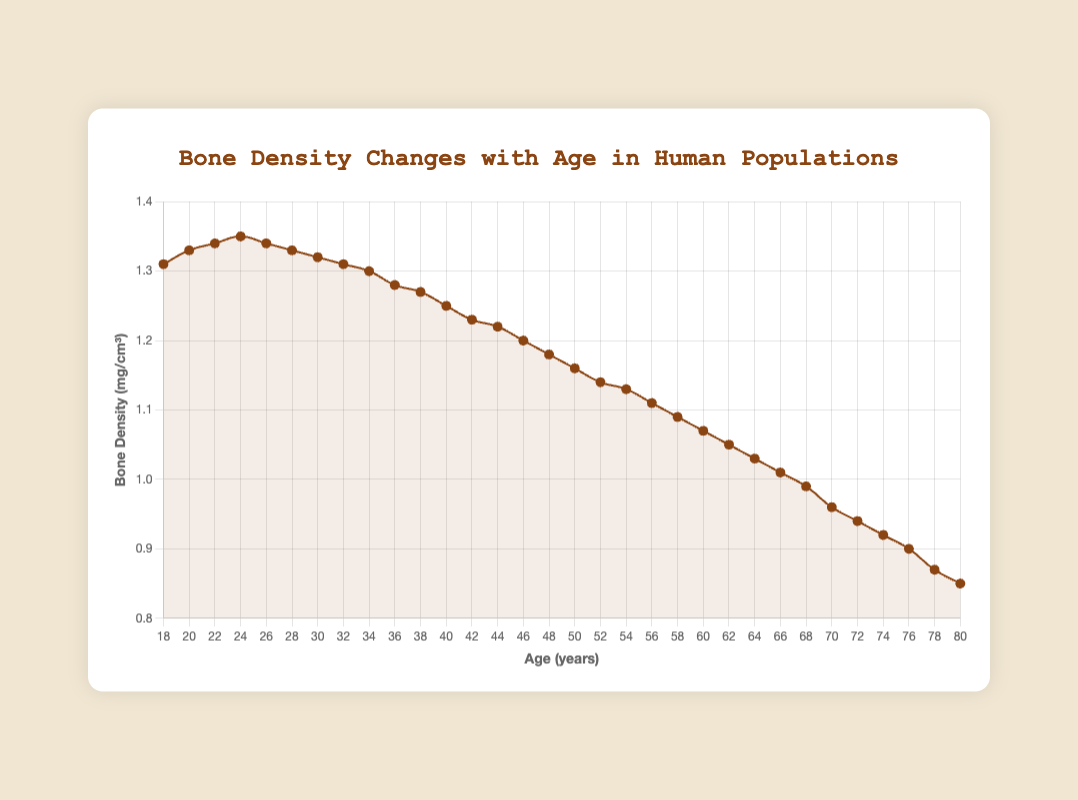How does bone density change between the ages of 18 and 28? Refer to the curve in the plot, bone density increases from 1.31 mg/cm³ to 1.33 mg/cm³ between the ages of 18 and 28.
Answer: It increases At what age does bone density peak? Inspect the peak point of the curve; bone density peaks at age 24 at 1.35 mg/cm³.
Answer: 24 years How much does bone density decline from age 24 to 50? From the figure, bone density at age 24 is 1.35 mg/cm³ and at age 50 is 1.16 mg/cm³. The decline is 1.35 - 1.16 = 0.19 mg/cm³.
Answer: 0.19 mg/cm³ Compare the bone density at ages 30 and 60. Which one is higher? The bone density at age 30 is 1.32 mg/cm³ and at age 60 is 1.07 mg/cm³. Clearly, 1.32 mg/cm³ is higher than 1.07 mg/cm³.
Answer: Age 30 What is the average bone density between ages 18 and 24? Sum the bone densities: 1.31 + 1.33 + 1.34 + 1.35 = 5.33, and divide by 4. Average = 5.33 / 4 = 1.3325 mg/cm³.
Answer: 1.33 mg/cm³ By how much does bone density decrease from age 30 to 80? From the figure, bone density at 30 is 1.32 mg/cm³ and at 80 is 0.85 mg/cm³. The decrease is 1.32 - 0.85 = 0.47 mg/cm³.
Answer: 0.47 mg/cm³ At what age does bone density first drop below 1.0 mg/cm³? Refer to the curve; bone density drops below 1.0 mg/cm³ at age 68 with a bone density of 0.99 mg/cm³.
Answer: Age 68 What is the rate of bone density change from ages 40 to 60? Bone density at age 40 is 1.25 mg/cm³ and at age 60 is 1.07 mg/cm³. The change over 20 years is 1.25 - 1.07 = 0.18 mg/cm³; the rate per year is 0.18 / 20 = 0.009 mg/cm³ per year.
Answer: 0.009 mg/cm³ per year What is the bone density at age 40 relative to the bone density at age 24? Bone density at age 40 is 1.25 mg/cm³ and at age 24 is 1.35 mg/cm³. 1.25 / 1.35 ≈ 0.926. So, bone density at age 40 is about 93% of the value at age 24.
Answer: 93% 